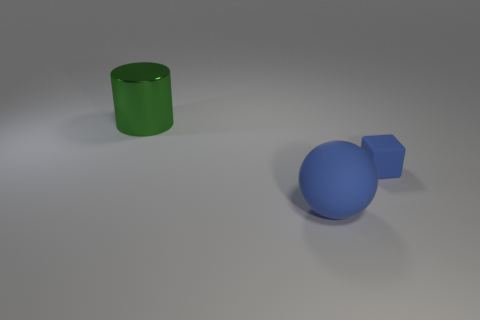Are there any other things that are the same shape as the tiny blue rubber thing?
Your answer should be compact. No. Is there a small rubber thing of the same color as the small rubber cube?
Your answer should be compact. No. What size is the rubber sphere?
Offer a terse response. Large. Does the rubber block have the same color as the large matte object?
Keep it short and to the point. Yes. What number of things are either small green cylinders or big objects behind the tiny matte thing?
Make the answer very short. 1. There is a rubber thing behind the blue thing left of the tiny rubber cube; how many big objects are in front of it?
Your answer should be very brief. 1. There is a ball that is the same color as the small block; what is it made of?
Make the answer very short. Rubber. What number of small blue metallic blocks are there?
Ensure brevity in your answer.  0. Do the blue object on the right side of the blue matte sphere and the big rubber object have the same size?
Make the answer very short. No. How many metallic objects are large purple blocks or spheres?
Make the answer very short. 0. 